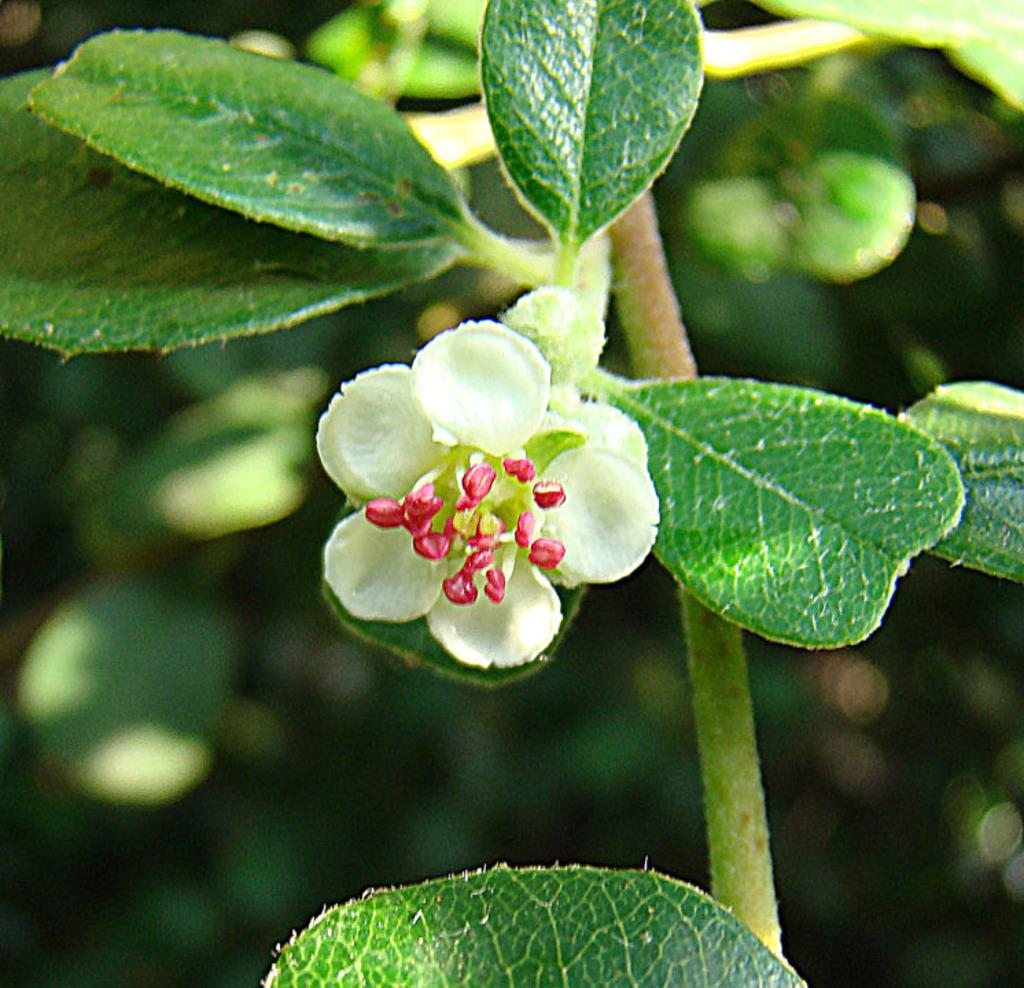What type of plant is present in the image? There is a flower in the image. What color is the flower? The flower is white in color. What other color can be seen in the image besides white? There is a pink object in the image. Where is the pink object located in relation to the flower and leaves? The pink object is between the flower and the leaves. What else is visible in the image besides the flower and pink object? There are leaves visible in the image. What type of lunchroom is depicted in the image? There is no lunchroom present in the image; it features a flower, a pink object, and leaves. How does the haircut of the person in the image contribute to the overall composition? There is no person present in the image, so there is no haircut to consider. 